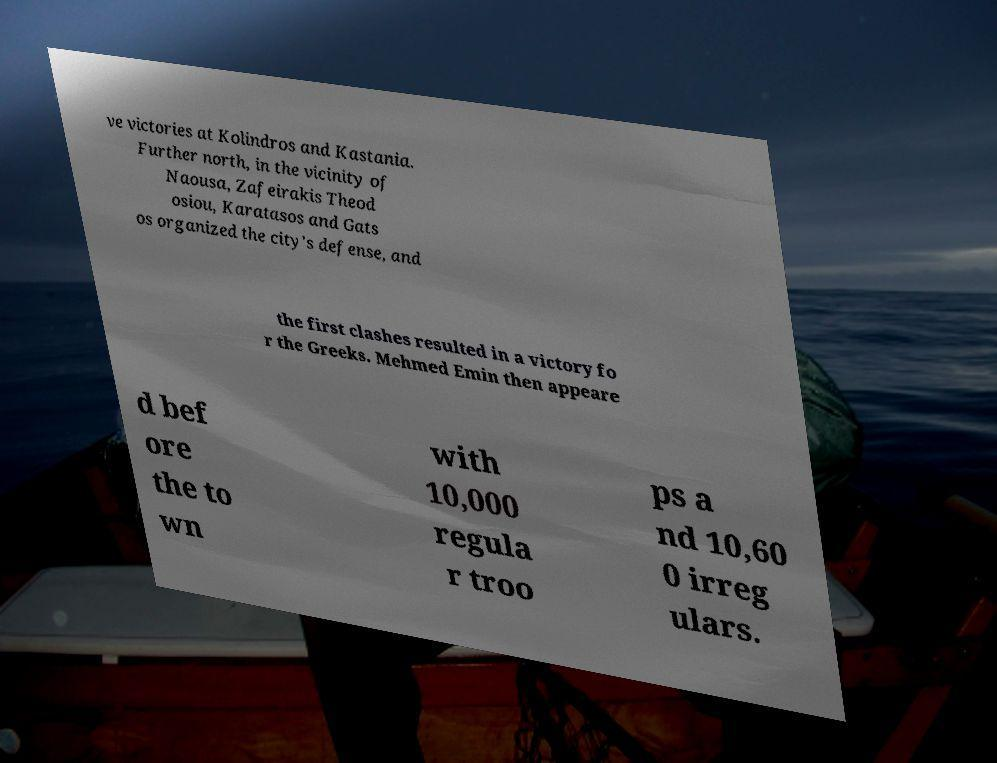I need the written content from this picture converted into text. Can you do that? ve victories at Kolindros and Kastania. Further north, in the vicinity of Naousa, Zafeirakis Theod osiou, Karatasos and Gats os organized the city's defense, and the first clashes resulted in a victory fo r the Greeks. Mehmed Emin then appeare d bef ore the to wn with 10,000 regula r troo ps a nd 10,60 0 irreg ulars. 